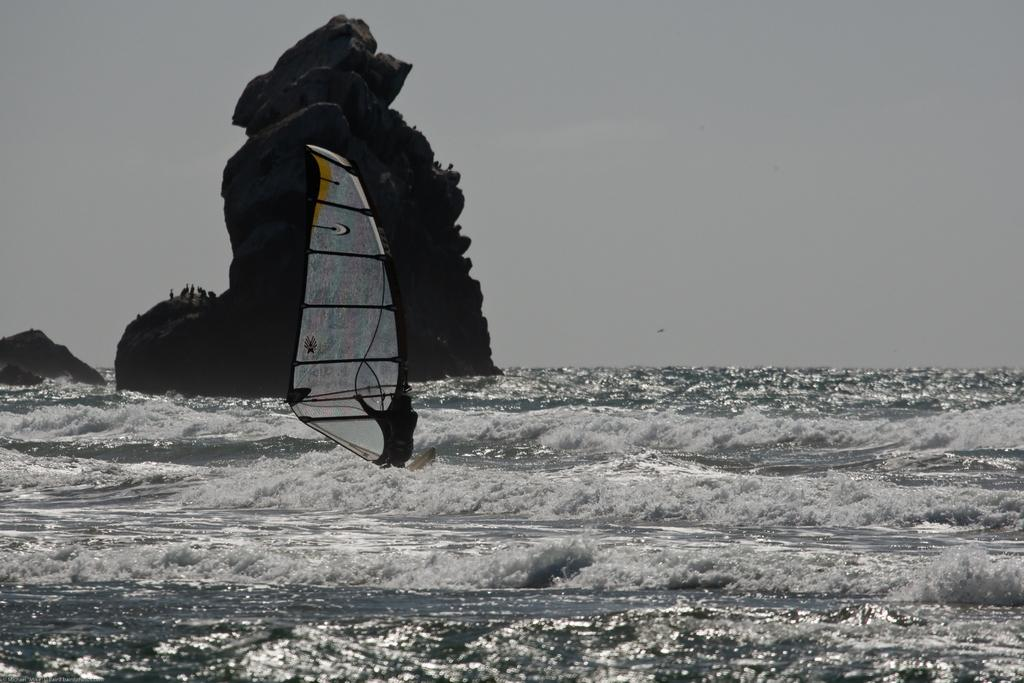What is the main subject in the center of the image? There is water in the center of the image. What type of landform can be seen in the image? There is a hill in the image. What is attached to the water in the image? There is a sail in the image. What can be seen in the background of the image? The sky is visible in the background of the image. How many minutes does it take for the smoke to clear in the image? There is no smoke present in the image, so it is not possible to determine how long it would take for it to clear. 